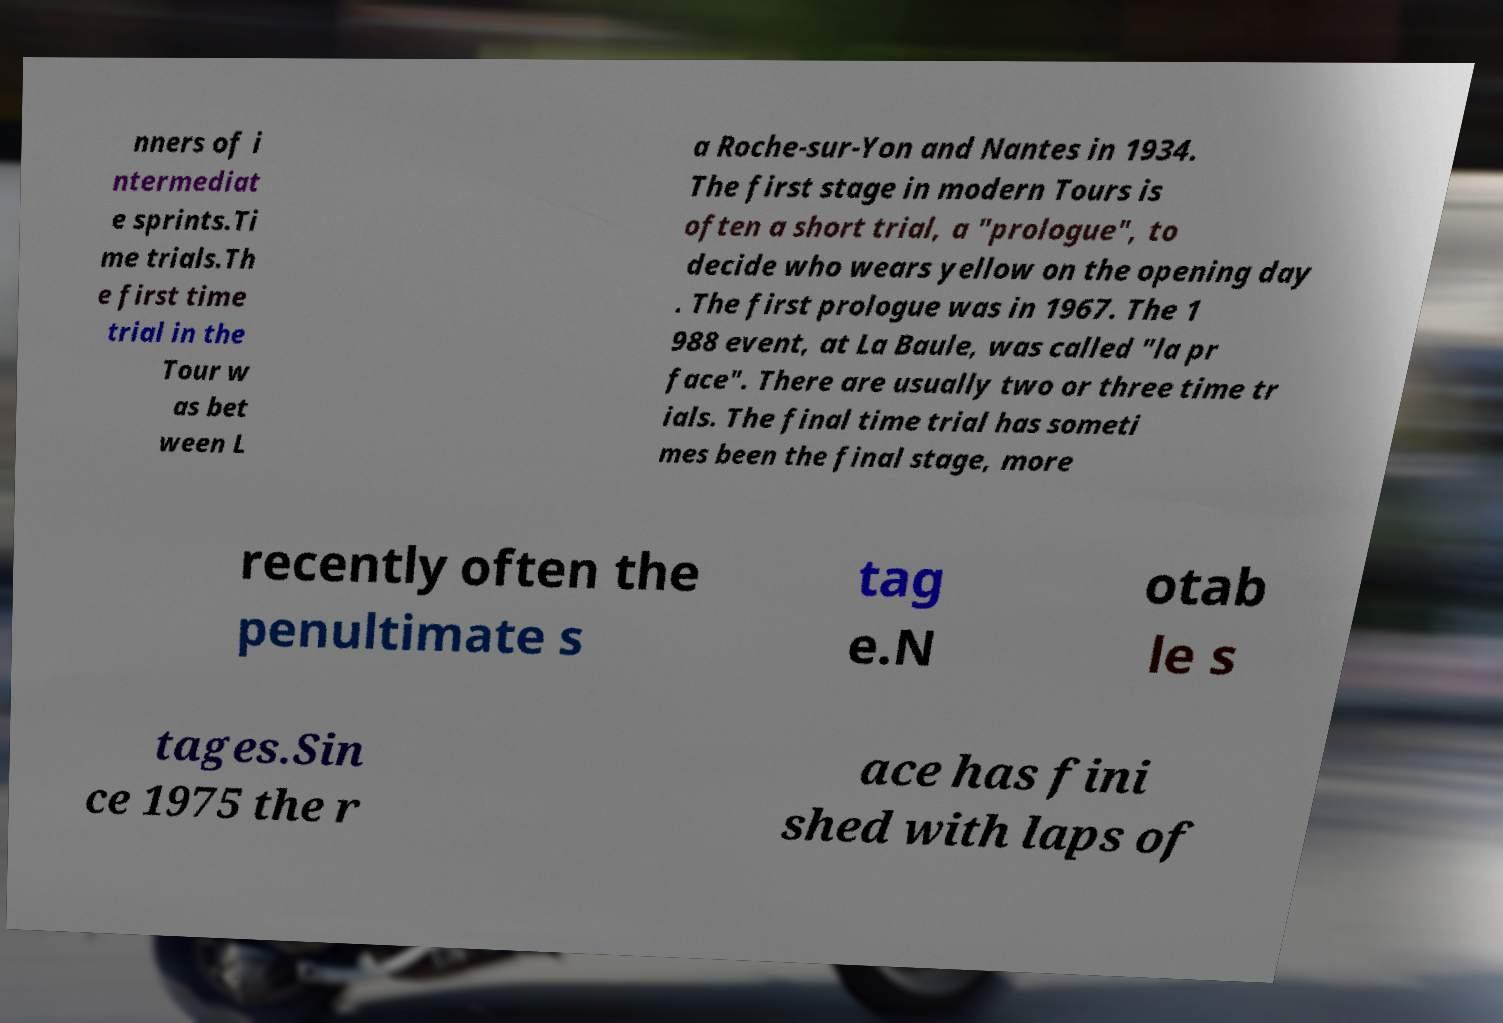Please read and relay the text visible in this image. What does it say? nners of i ntermediat e sprints.Ti me trials.Th e first time trial in the Tour w as bet ween L a Roche-sur-Yon and Nantes in 1934. The first stage in modern Tours is often a short trial, a "prologue", to decide who wears yellow on the opening day . The first prologue was in 1967. The 1 988 event, at La Baule, was called "la pr face". There are usually two or three time tr ials. The final time trial has someti mes been the final stage, more recently often the penultimate s tag e.N otab le s tages.Sin ce 1975 the r ace has fini shed with laps of 